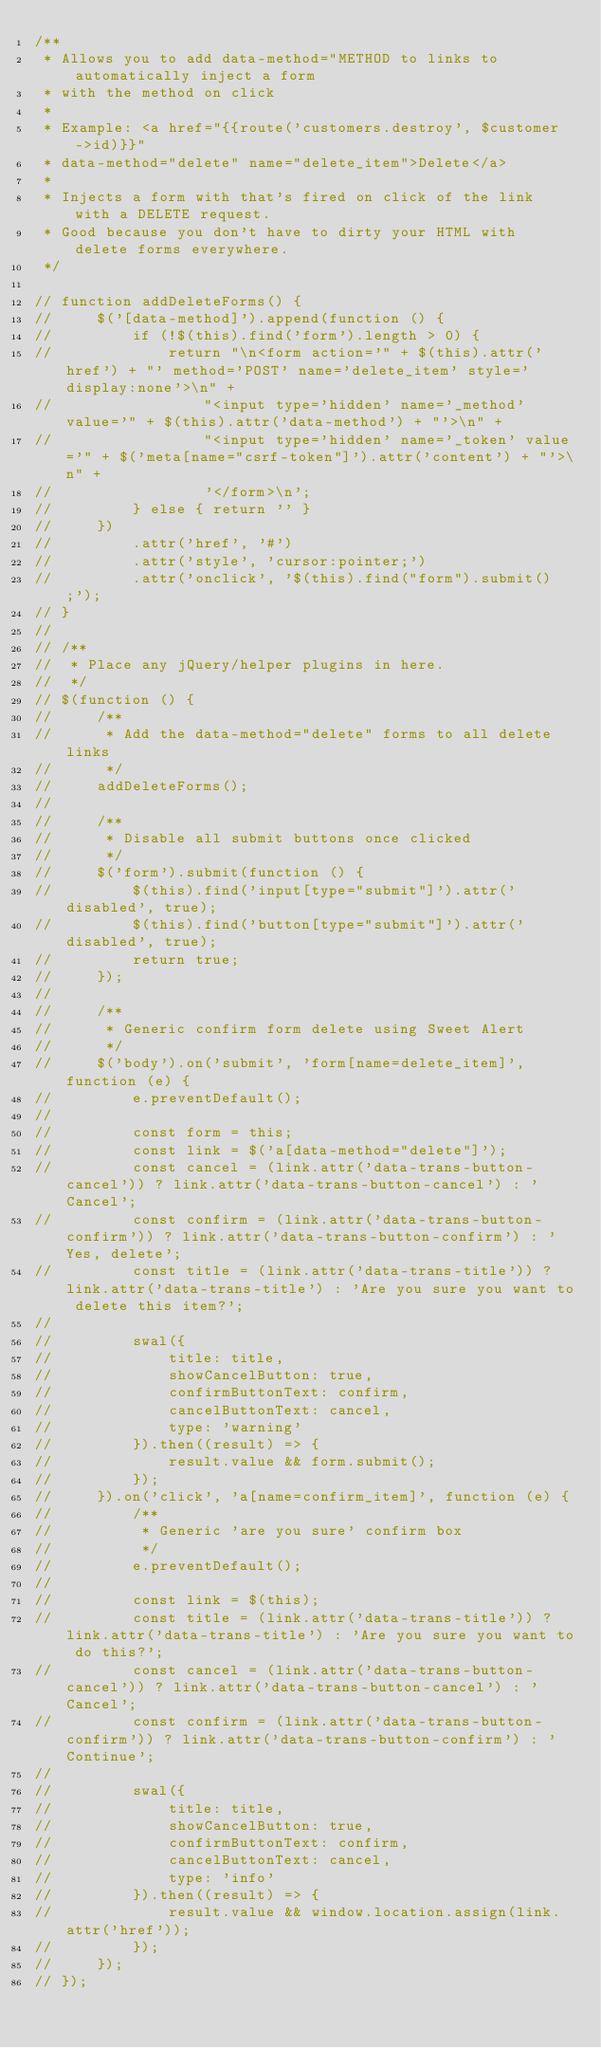<code> <loc_0><loc_0><loc_500><loc_500><_JavaScript_>/**
 * Allows you to add data-method="METHOD to links to automatically inject a form
 * with the method on click
 *
 * Example: <a href="{{route('customers.destroy', $customer->id)}}"
 * data-method="delete" name="delete_item">Delete</a>
 *
 * Injects a form with that's fired on click of the link with a DELETE request.
 * Good because you don't have to dirty your HTML with delete forms everywhere.
 */

// function addDeleteForms() {
//     $('[data-method]').append(function () {
//         if (!$(this).find('form').length > 0) {
//             return "\n<form action='" + $(this).attr('href') + "' method='POST' name='delete_item' style='display:none'>\n" +
//                 "<input type='hidden' name='_method' value='" + $(this).attr('data-method') + "'>\n" +
//                 "<input type='hidden' name='_token' value='" + $('meta[name="csrf-token"]').attr('content') + "'>\n" +
//                 '</form>\n';
//         } else { return '' }
//     })
//         .attr('href', '#')
//         .attr('style', 'cursor:pointer;')
//         .attr('onclick', '$(this).find("form").submit();');
// }
//
// /**
//  * Place any jQuery/helper plugins in here.
//  */
// $(function () {
//     /**
//      * Add the data-method="delete" forms to all delete links
//      */
//     addDeleteForms();
//
//     /**
//      * Disable all submit buttons once clicked
//      */
//     $('form').submit(function () {
//         $(this).find('input[type="submit"]').attr('disabled', true);
//         $(this).find('button[type="submit"]').attr('disabled', true);
//         return true;
//     });
//
//     /**
//      * Generic confirm form delete using Sweet Alert
//      */
//     $('body').on('submit', 'form[name=delete_item]', function (e) {
//         e.preventDefault();
//
//         const form = this;
//         const link = $('a[data-method="delete"]');
//         const cancel = (link.attr('data-trans-button-cancel')) ? link.attr('data-trans-button-cancel') : 'Cancel';
//         const confirm = (link.attr('data-trans-button-confirm')) ? link.attr('data-trans-button-confirm') : 'Yes, delete';
//         const title = (link.attr('data-trans-title')) ? link.attr('data-trans-title') : 'Are you sure you want to delete this item?';
//
//         swal({
//             title: title,
//             showCancelButton: true,
//             confirmButtonText: confirm,
//             cancelButtonText: cancel,
//             type: 'warning'
//         }).then((result) => {
//             result.value && form.submit();
//         });
//     }).on('click', 'a[name=confirm_item]', function (e) {
//         /**
//          * Generic 'are you sure' confirm box
//          */
//         e.preventDefault();
//
//         const link = $(this);
//         const title = (link.attr('data-trans-title')) ? link.attr('data-trans-title') : 'Are you sure you want to do this?';
//         const cancel = (link.attr('data-trans-button-cancel')) ? link.attr('data-trans-button-cancel') : 'Cancel';
//         const confirm = (link.attr('data-trans-button-confirm')) ? link.attr('data-trans-button-confirm') : 'Continue';
//
//         swal({
//             title: title,
//             showCancelButton: true,
//             confirmButtonText: confirm,
//             cancelButtonText: cancel,
//             type: 'info'
//         }).then((result) => {
//             result.value && window.location.assign(link.attr('href'));
//         });
//     });
// });
</code> 